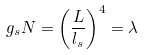Convert formula to latex. <formula><loc_0><loc_0><loc_500><loc_500>g _ { s } N = \left ( \frac { L } { l _ { s } } \right ) ^ { 4 } = \lambda</formula> 